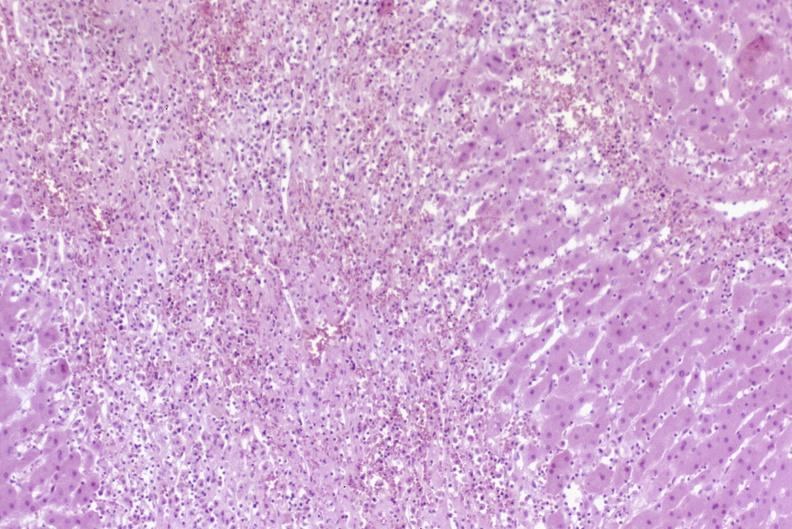s purulent sinusitis present?
Answer the question using a single word or phrase. No 